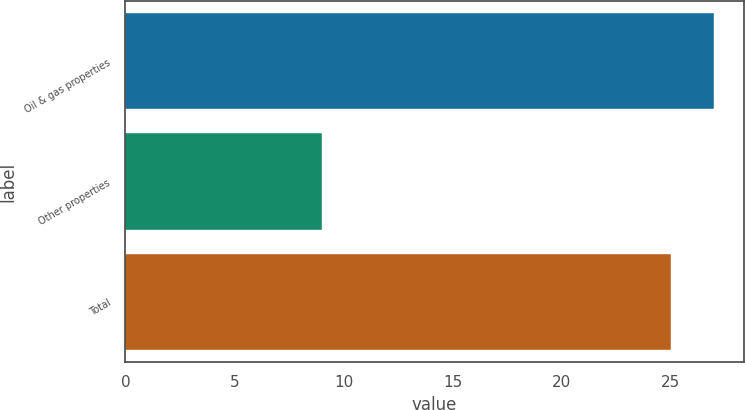Convert chart. <chart><loc_0><loc_0><loc_500><loc_500><bar_chart><fcel>Oil & gas properties<fcel>Other properties<fcel>Total<nl><fcel>27<fcel>9<fcel>25<nl></chart> 